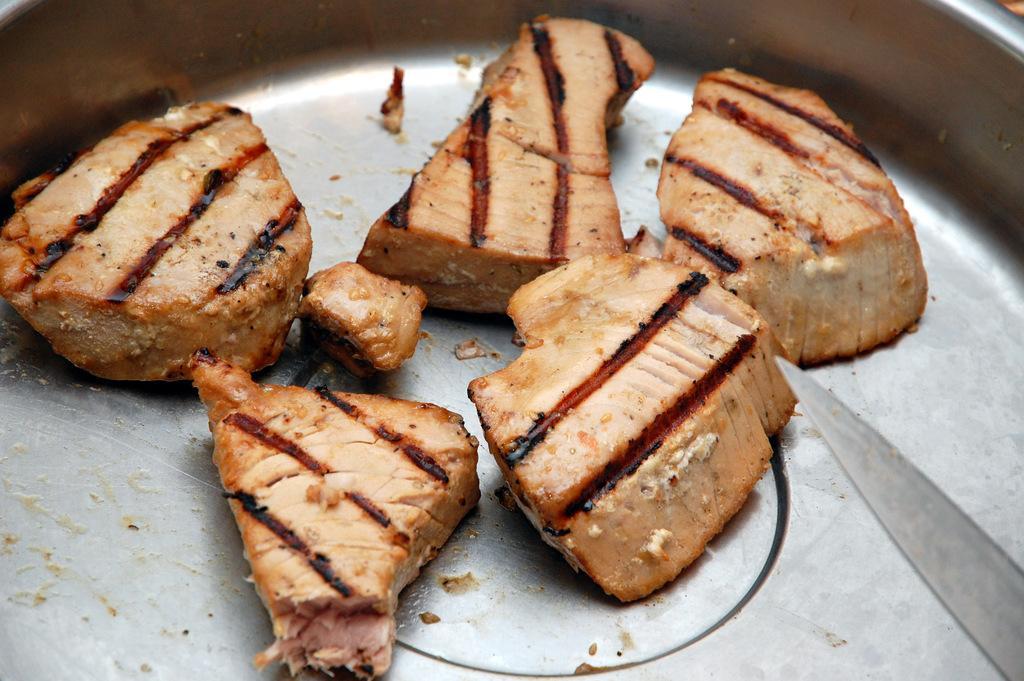Describe this image in one or two sentences. In this picture, we see a steel tray containing the eatables and a knife. 